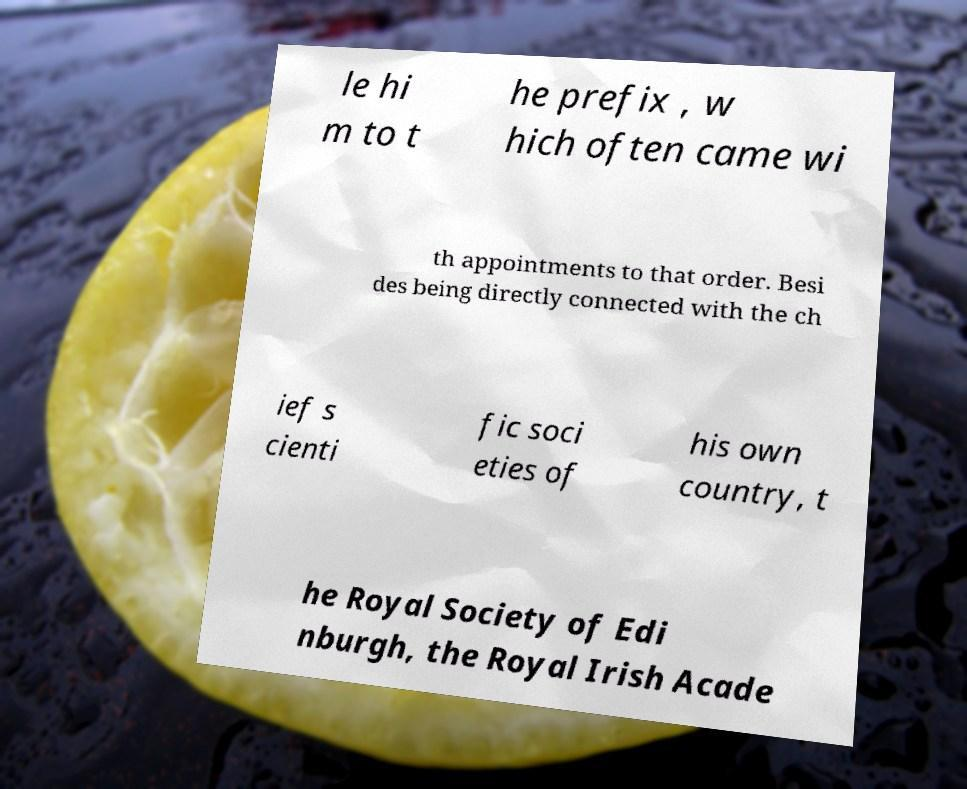For documentation purposes, I need the text within this image transcribed. Could you provide that? le hi m to t he prefix , w hich often came wi th appointments to that order. Besi des being directly connected with the ch ief s cienti fic soci eties of his own country, t he Royal Society of Edi nburgh, the Royal Irish Acade 